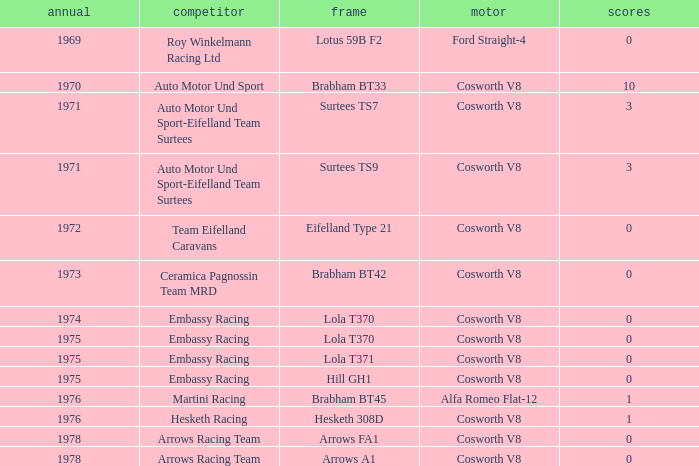Who was the entrant in 1971? Auto Motor Und Sport-Eifelland Team Surtees, Auto Motor Und Sport-Eifelland Team Surtees. 